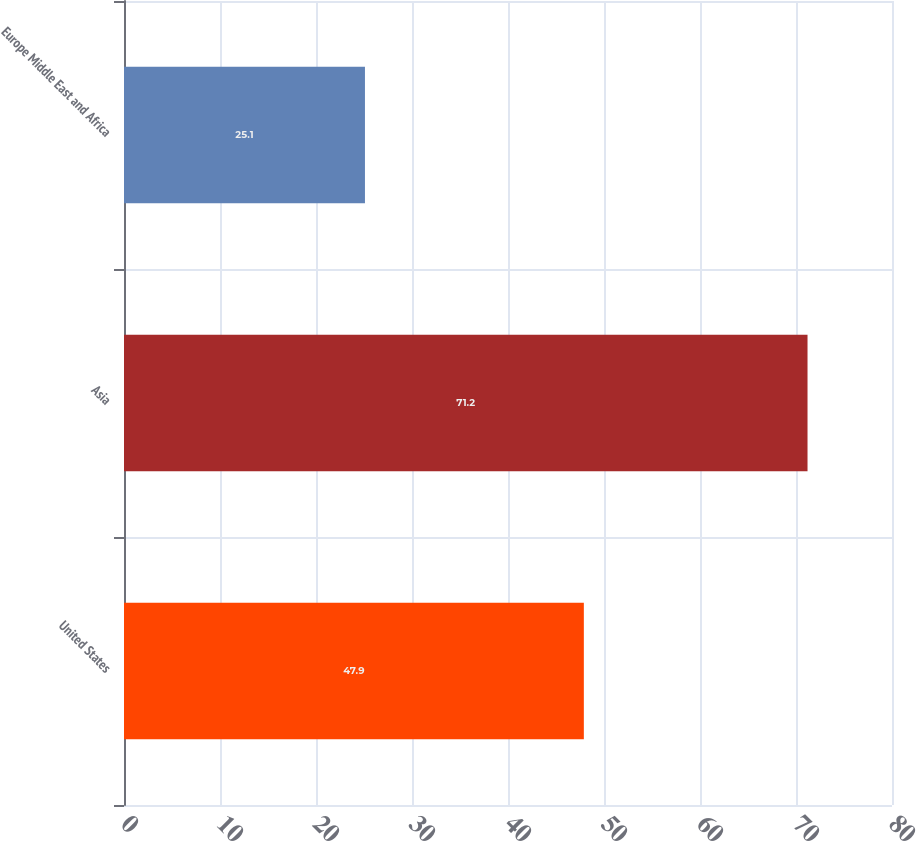Convert chart to OTSL. <chart><loc_0><loc_0><loc_500><loc_500><bar_chart><fcel>United States<fcel>Asia<fcel>Europe Middle East and Africa<nl><fcel>47.9<fcel>71.2<fcel>25.1<nl></chart> 